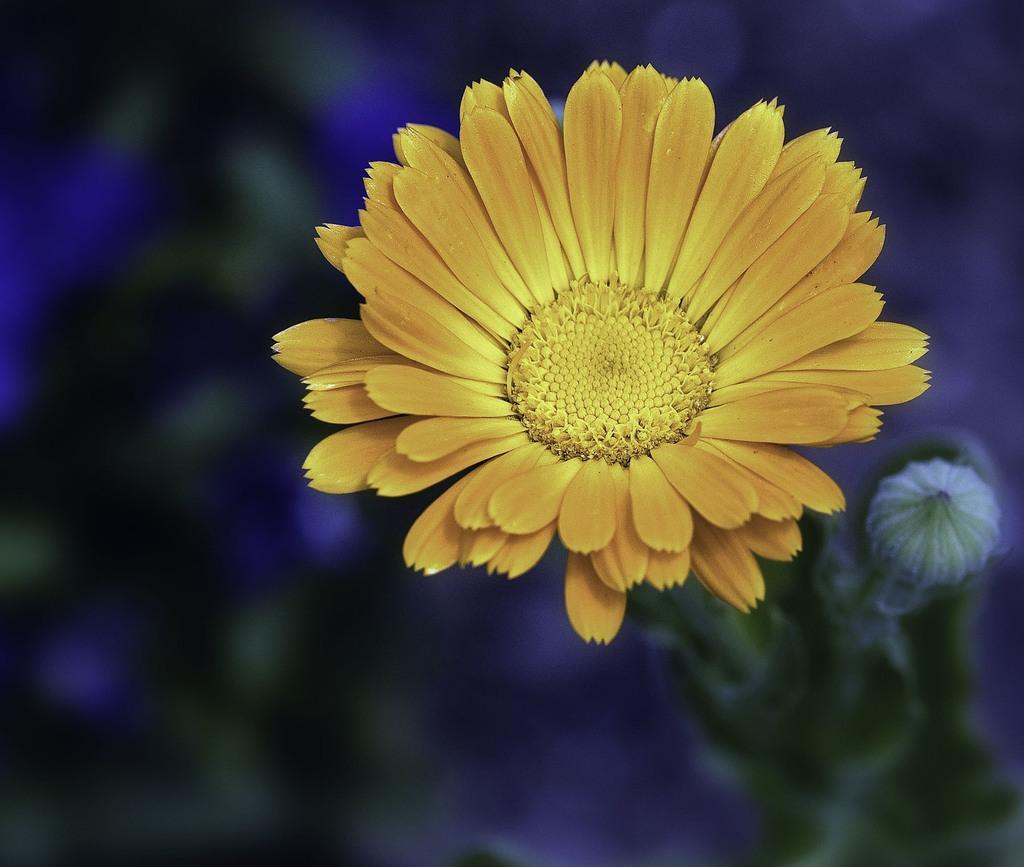Can you describe this image briefly? In the middle of this image, there is a plant having yellow color flower. And the background is blurred. 